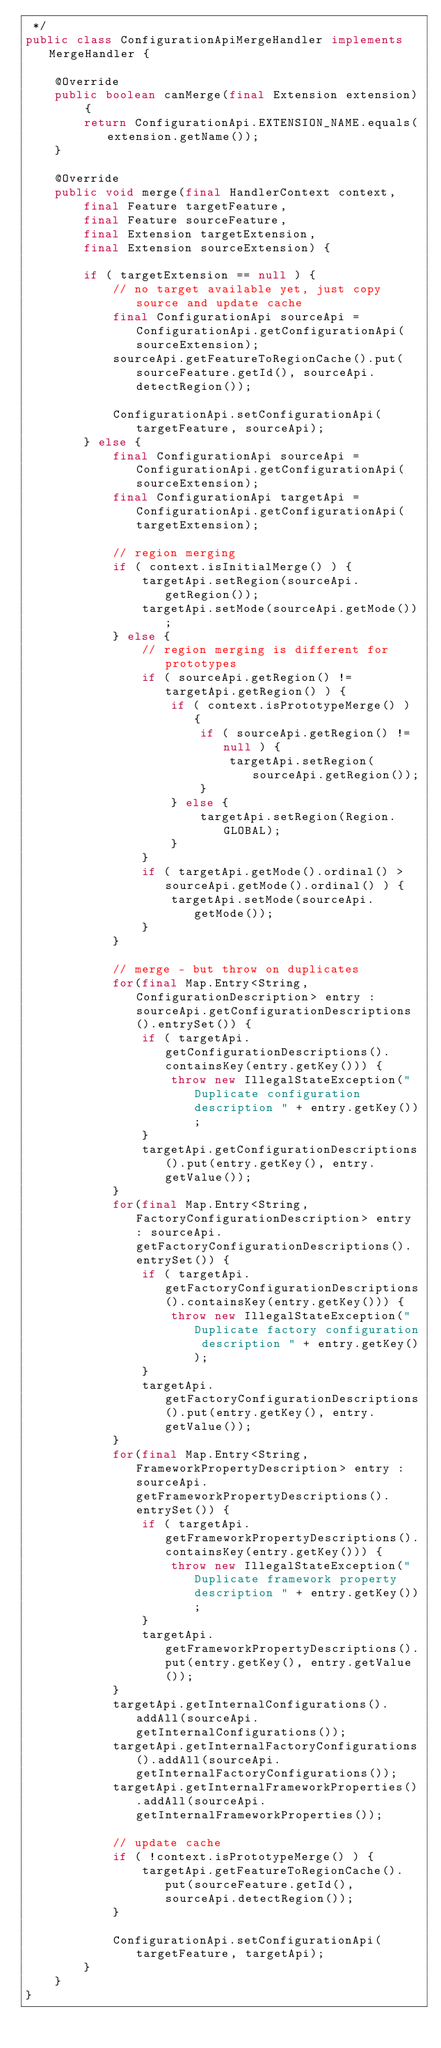<code> <loc_0><loc_0><loc_500><loc_500><_Java_> */
public class ConfigurationApiMergeHandler implements MergeHandler {

    @Override
    public boolean canMerge(final Extension extension) {
        return ConfigurationApi.EXTENSION_NAME.equals(extension.getName());
    }

    @Override
    public void merge(final HandlerContext context, 
        final Feature targetFeature, 
        final Feature sourceFeature, 
        final Extension targetExtension, 
        final Extension sourceExtension) {

        if ( targetExtension == null ) {
            // no target available yet, just copy source and update cache
            final ConfigurationApi sourceApi = ConfigurationApi.getConfigurationApi(sourceExtension);
            sourceApi.getFeatureToRegionCache().put(sourceFeature.getId(), sourceApi.detectRegion());

            ConfigurationApi.setConfigurationApi(targetFeature, sourceApi);
        } else {
            final ConfigurationApi sourceApi = ConfigurationApi.getConfigurationApi(sourceExtension);
            final ConfigurationApi targetApi = ConfigurationApi.getConfigurationApi(targetExtension);

            // region merging
            if ( context.isInitialMerge() ) {
                targetApi.setRegion(sourceApi.getRegion());
                targetApi.setMode(sourceApi.getMode());
            } else {
                // region merging is different for prototypes
                if ( sourceApi.getRegion() != targetApi.getRegion() ) {
                    if ( context.isPrototypeMerge() ) {
                        if ( sourceApi.getRegion() != null ) {
                            targetApi.setRegion(sourceApi.getRegion());
                        }
                    } else {                    
                        targetApi.setRegion(Region.GLOBAL);
                    }
                }
                if ( targetApi.getMode().ordinal() > sourceApi.getMode().ordinal() ) {
                    targetApi.setMode(sourceApi.getMode());
                }
            }

            // merge - but throw on duplicates
            for(final Map.Entry<String, ConfigurationDescription> entry : sourceApi.getConfigurationDescriptions().entrySet()) {
                if ( targetApi.getConfigurationDescriptions().containsKey(entry.getKey())) {
                    throw new IllegalStateException("Duplicate configuration description " + entry.getKey());
                }
                targetApi.getConfigurationDescriptions().put(entry.getKey(), entry.getValue());
            }
            for(final Map.Entry<String, FactoryConfigurationDescription> entry : sourceApi.getFactoryConfigurationDescriptions().entrySet()) {
                if ( targetApi.getFactoryConfigurationDescriptions().containsKey(entry.getKey())) {
                    throw new IllegalStateException("Duplicate factory configuration description " + entry.getKey());
                }
                targetApi.getFactoryConfigurationDescriptions().put(entry.getKey(), entry.getValue());
            }
            for(final Map.Entry<String, FrameworkPropertyDescription> entry : sourceApi.getFrameworkPropertyDescriptions().entrySet()) {
                if ( targetApi.getFrameworkPropertyDescriptions().containsKey(entry.getKey())) {
                    throw new IllegalStateException("Duplicate framework property description " + entry.getKey());
                }
                targetApi.getFrameworkPropertyDescriptions().put(entry.getKey(), entry.getValue());
            }
            targetApi.getInternalConfigurations().addAll(sourceApi.getInternalConfigurations());
            targetApi.getInternalFactoryConfigurations().addAll(sourceApi.getInternalFactoryConfigurations());
            targetApi.getInternalFrameworkProperties().addAll(sourceApi.getInternalFrameworkProperties());

            // update cache
            if ( !context.isPrototypeMerge() ) {
                targetApi.getFeatureToRegionCache().put(sourceFeature.getId(), sourceApi.detectRegion());
            }
            
            ConfigurationApi.setConfigurationApi(targetFeature, targetApi);
        }
    }
}
</code> 